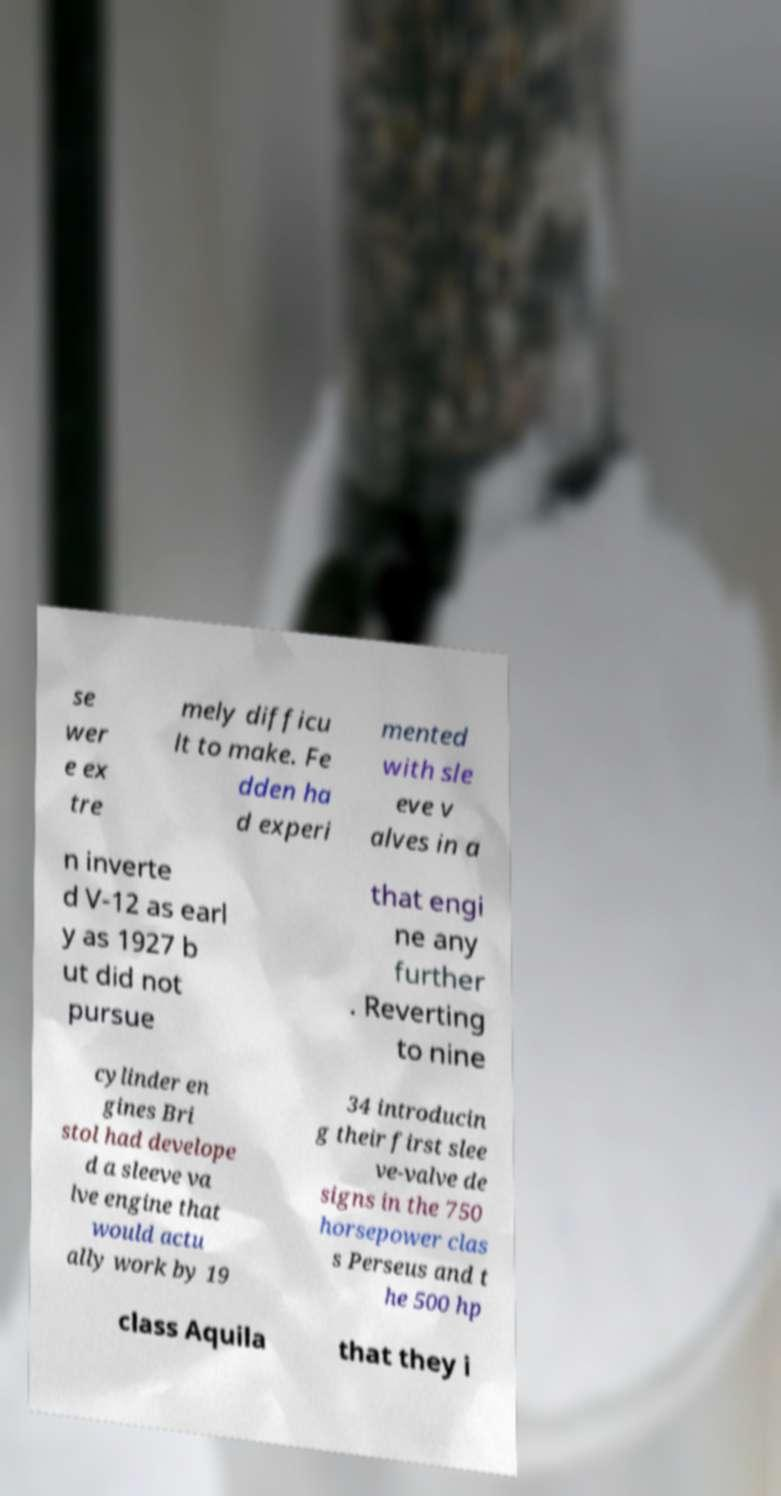Please read and relay the text visible in this image. What does it say? se wer e ex tre mely difficu lt to make. Fe dden ha d experi mented with sle eve v alves in a n inverte d V-12 as earl y as 1927 b ut did not pursue that engi ne any further . Reverting to nine cylinder en gines Bri stol had develope d a sleeve va lve engine that would actu ally work by 19 34 introducin g their first slee ve-valve de signs in the 750 horsepower clas s Perseus and t he 500 hp class Aquila that they i 